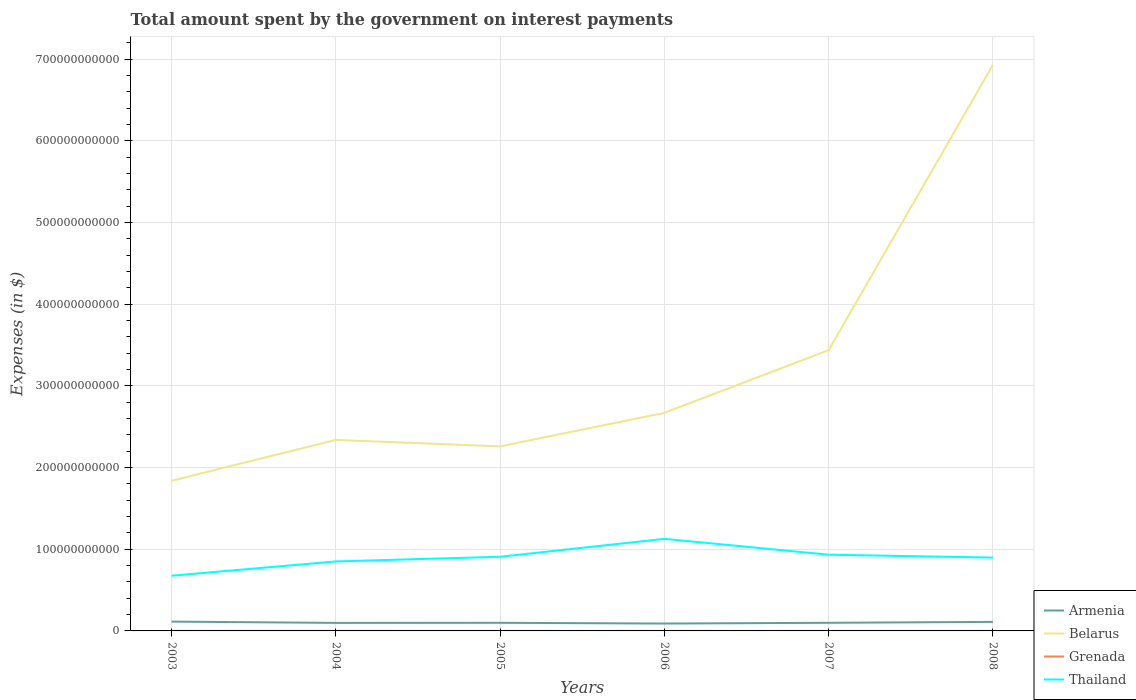How many different coloured lines are there?
Give a very brief answer. 4. Does the line corresponding to Belarus intersect with the line corresponding to Grenada?
Your answer should be very brief. No. Is the number of lines equal to the number of legend labels?
Your answer should be compact. Yes. Across all years, what is the maximum amount spent on interest payments by the government in Thailand?
Keep it short and to the point. 6.76e+1. In which year was the amount spent on interest payments by the government in Grenada maximum?
Ensure brevity in your answer.  2005. What is the total amount spent on interest payments by the government in Belarus in the graph?
Your answer should be very brief. 7.93e+09. What is the difference between the highest and the second highest amount spent on interest payments by the government in Grenada?
Your answer should be very brief. 4.40e+07. What is the difference between the highest and the lowest amount spent on interest payments by the government in Belarus?
Provide a succinct answer. 2. Is the amount spent on interest payments by the government in Thailand strictly greater than the amount spent on interest payments by the government in Grenada over the years?
Offer a very short reply. No. What is the difference between two consecutive major ticks on the Y-axis?
Provide a short and direct response. 1.00e+11. Are the values on the major ticks of Y-axis written in scientific E-notation?
Give a very brief answer. No. What is the title of the graph?
Your answer should be compact. Total amount spent by the government on interest payments. Does "Brunei Darussalam" appear as one of the legend labels in the graph?
Provide a succinct answer. No. What is the label or title of the X-axis?
Keep it short and to the point. Years. What is the label or title of the Y-axis?
Offer a terse response. Expenses (in $). What is the Expenses (in $) in Armenia in 2003?
Offer a terse response. 1.14e+1. What is the Expenses (in $) of Belarus in 2003?
Offer a terse response. 1.84e+11. What is the Expenses (in $) of Grenada in 2003?
Ensure brevity in your answer.  6.31e+07. What is the Expenses (in $) in Thailand in 2003?
Offer a very short reply. 6.76e+1. What is the Expenses (in $) of Armenia in 2004?
Offer a very short reply. 9.83e+09. What is the Expenses (in $) of Belarus in 2004?
Your response must be concise. 2.34e+11. What is the Expenses (in $) in Grenada in 2004?
Keep it short and to the point. 7.18e+07. What is the Expenses (in $) of Thailand in 2004?
Make the answer very short. 8.51e+1. What is the Expenses (in $) in Armenia in 2005?
Your answer should be very brief. 9.93e+09. What is the Expenses (in $) of Belarus in 2005?
Offer a very short reply. 2.26e+11. What is the Expenses (in $) in Grenada in 2005?
Offer a terse response. 2.78e+07. What is the Expenses (in $) of Thailand in 2005?
Your response must be concise. 9.08e+1. What is the Expenses (in $) in Armenia in 2006?
Your response must be concise. 9.02e+09. What is the Expenses (in $) of Belarus in 2006?
Your response must be concise. 2.67e+11. What is the Expenses (in $) of Grenada in 2006?
Your response must be concise. 2.90e+07. What is the Expenses (in $) of Thailand in 2006?
Ensure brevity in your answer.  1.13e+11. What is the Expenses (in $) in Armenia in 2007?
Give a very brief answer. 9.96e+09. What is the Expenses (in $) of Belarus in 2007?
Offer a very short reply. 3.44e+11. What is the Expenses (in $) in Grenada in 2007?
Provide a succinct answer. 3.30e+07. What is the Expenses (in $) of Thailand in 2007?
Provide a succinct answer. 9.33e+1. What is the Expenses (in $) in Armenia in 2008?
Keep it short and to the point. 1.11e+1. What is the Expenses (in $) in Belarus in 2008?
Your response must be concise. 6.93e+11. What is the Expenses (in $) in Grenada in 2008?
Your answer should be compact. 3.49e+07. What is the Expenses (in $) in Thailand in 2008?
Provide a succinct answer. 8.98e+1. Across all years, what is the maximum Expenses (in $) of Armenia?
Your response must be concise. 1.14e+1. Across all years, what is the maximum Expenses (in $) in Belarus?
Ensure brevity in your answer.  6.93e+11. Across all years, what is the maximum Expenses (in $) of Grenada?
Make the answer very short. 7.18e+07. Across all years, what is the maximum Expenses (in $) of Thailand?
Provide a succinct answer. 1.13e+11. Across all years, what is the minimum Expenses (in $) of Armenia?
Make the answer very short. 9.02e+09. Across all years, what is the minimum Expenses (in $) in Belarus?
Your answer should be very brief. 1.84e+11. Across all years, what is the minimum Expenses (in $) of Grenada?
Your answer should be compact. 2.78e+07. Across all years, what is the minimum Expenses (in $) of Thailand?
Give a very brief answer. 6.76e+1. What is the total Expenses (in $) in Armenia in the graph?
Your answer should be very brief. 6.12e+1. What is the total Expenses (in $) of Belarus in the graph?
Give a very brief answer. 1.95e+12. What is the total Expenses (in $) in Grenada in the graph?
Your response must be concise. 2.60e+08. What is the total Expenses (in $) of Thailand in the graph?
Make the answer very short. 5.39e+11. What is the difference between the Expenses (in $) of Armenia in 2003 and that in 2004?
Give a very brief answer. 1.56e+09. What is the difference between the Expenses (in $) in Belarus in 2003 and that in 2004?
Provide a short and direct response. -5.00e+1. What is the difference between the Expenses (in $) of Grenada in 2003 and that in 2004?
Your response must be concise. -8.70e+06. What is the difference between the Expenses (in $) in Thailand in 2003 and that in 2004?
Offer a very short reply. -1.75e+1. What is the difference between the Expenses (in $) of Armenia in 2003 and that in 2005?
Give a very brief answer. 1.46e+09. What is the difference between the Expenses (in $) of Belarus in 2003 and that in 2005?
Provide a short and direct response. -4.20e+1. What is the difference between the Expenses (in $) of Grenada in 2003 and that in 2005?
Keep it short and to the point. 3.53e+07. What is the difference between the Expenses (in $) of Thailand in 2003 and that in 2005?
Give a very brief answer. -2.32e+1. What is the difference between the Expenses (in $) of Armenia in 2003 and that in 2006?
Offer a very short reply. 2.37e+09. What is the difference between the Expenses (in $) of Belarus in 2003 and that in 2006?
Ensure brevity in your answer.  -8.31e+1. What is the difference between the Expenses (in $) of Grenada in 2003 and that in 2006?
Give a very brief answer. 3.41e+07. What is the difference between the Expenses (in $) of Thailand in 2003 and that in 2006?
Ensure brevity in your answer.  -4.52e+1. What is the difference between the Expenses (in $) of Armenia in 2003 and that in 2007?
Provide a succinct answer. 1.44e+09. What is the difference between the Expenses (in $) in Belarus in 2003 and that in 2007?
Offer a very short reply. -1.60e+11. What is the difference between the Expenses (in $) in Grenada in 2003 and that in 2007?
Offer a very short reply. 3.01e+07. What is the difference between the Expenses (in $) of Thailand in 2003 and that in 2007?
Give a very brief answer. -2.57e+1. What is the difference between the Expenses (in $) in Armenia in 2003 and that in 2008?
Ensure brevity in your answer.  3.44e+08. What is the difference between the Expenses (in $) in Belarus in 2003 and that in 2008?
Offer a very short reply. -5.09e+11. What is the difference between the Expenses (in $) of Grenada in 2003 and that in 2008?
Offer a very short reply. 2.82e+07. What is the difference between the Expenses (in $) in Thailand in 2003 and that in 2008?
Give a very brief answer. -2.22e+1. What is the difference between the Expenses (in $) in Armenia in 2004 and that in 2005?
Offer a terse response. -9.82e+07. What is the difference between the Expenses (in $) of Belarus in 2004 and that in 2005?
Your response must be concise. 7.93e+09. What is the difference between the Expenses (in $) in Grenada in 2004 and that in 2005?
Offer a terse response. 4.40e+07. What is the difference between the Expenses (in $) of Thailand in 2004 and that in 2005?
Your answer should be very brief. -5.71e+09. What is the difference between the Expenses (in $) in Armenia in 2004 and that in 2006?
Ensure brevity in your answer.  8.10e+08. What is the difference between the Expenses (in $) of Belarus in 2004 and that in 2006?
Your answer should be very brief. -3.31e+1. What is the difference between the Expenses (in $) in Grenada in 2004 and that in 2006?
Provide a succinct answer. 4.28e+07. What is the difference between the Expenses (in $) of Thailand in 2004 and that in 2006?
Provide a short and direct response. -2.77e+1. What is the difference between the Expenses (in $) of Armenia in 2004 and that in 2007?
Provide a succinct answer. -1.22e+08. What is the difference between the Expenses (in $) in Belarus in 2004 and that in 2007?
Keep it short and to the point. -1.10e+11. What is the difference between the Expenses (in $) in Grenada in 2004 and that in 2007?
Give a very brief answer. 3.88e+07. What is the difference between the Expenses (in $) in Thailand in 2004 and that in 2007?
Provide a succinct answer. -8.24e+09. What is the difference between the Expenses (in $) of Armenia in 2004 and that in 2008?
Ensure brevity in your answer.  -1.22e+09. What is the difference between the Expenses (in $) in Belarus in 2004 and that in 2008?
Your response must be concise. -4.59e+11. What is the difference between the Expenses (in $) of Grenada in 2004 and that in 2008?
Offer a terse response. 3.69e+07. What is the difference between the Expenses (in $) of Thailand in 2004 and that in 2008?
Provide a short and direct response. -4.69e+09. What is the difference between the Expenses (in $) in Armenia in 2005 and that in 2006?
Keep it short and to the point. 9.09e+08. What is the difference between the Expenses (in $) in Belarus in 2005 and that in 2006?
Offer a very short reply. -4.11e+1. What is the difference between the Expenses (in $) of Grenada in 2005 and that in 2006?
Keep it short and to the point. -1.20e+06. What is the difference between the Expenses (in $) in Thailand in 2005 and that in 2006?
Your answer should be very brief. -2.19e+1. What is the difference between the Expenses (in $) of Armenia in 2005 and that in 2007?
Ensure brevity in your answer.  -2.36e+07. What is the difference between the Expenses (in $) in Belarus in 2005 and that in 2007?
Give a very brief answer. -1.18e+11. What is the difference between the Expenses (in $) in Grenada in 2005 and that in 2007?
Provide a succinct answer. -5.20e+06. What is the difference between the Expenses (in $) of Thailand in 2005 and that in 2007?
Ensure brevity in your answer.  -2.53e+09. What is the difference between the Expenses (in $) of Armenia in 2005 and that in 2008?
Offer a very short reply. -1.12e+09. What is the difference between the Expenses (in $) in Belarus in 2005 and that in 2008?
Provide a succinct answer. -4.67e+11. What is the difference between the Expenses (in $) in Grenada in 2005 and that in 2008?
Offer a very short reply. -7.10e+06. What is the difference between the Expenses (in $) in Thailand in 2005 and that in 2008?
Provide a succinct answer. 1.02e+09. What is the difference between the Expenses (in $) in Armenia in 2006 and that in 2007?
Ensure brevity in your answer.  -9.32e+08. What is the difference between the Expenses (in $) of Belarus in 2006 and that in 2007?
Keep it short and to the point. -7.68e+1. What is the difference between the Expenses (in $) in Thailand in 2006 and that in 2007?
Your answer should be compact. 1.94e+1. What is the difference between the Expenses (in $) of Armenia in 2006 and that in 2008?
Your answer should be compact. -2.03e+09. What is the difference between the Expenses (in $) in Belarus in 2006 and that in 2008?
Provide a succinct answer. -4.26e+11. What is the difference between the Expenses (in $) in Grenada in 2006 and that in 2008?
Give a very brief answer. -5.90e+06. What is the difference between the Expenses (in $) in Thailand in 2006 and that in 2008?
Make the answer very short. 2.30e+1. What is the difference between the Expenses (in $) of Armenia in 2007 and that in 2008?
Offer a terse response. -1.10e+09. What is the difference between the Expenses (in $) of Belarus in 2007 and that in 2008?
Offer a very short reply. -3.49e+11. What is the difference between the Expenses (in $) in Grenada in 2007 and that in 2008?
Your answer should be compact. -1.90e+06. What is the difference between the Expenses (in $) of Thailand in 2007 and that in 2008?
Your response must be concise. 3.55e+09. What is the difference between the Expenses (in $) of Armenia in 2003 and the Expenses (in $) of Belarus in 2004?
Ensure brevity in your answer.  -2.23e+11. What is the difference between the Expenses (in $) of Armenia in 2003 and the Expenses (in $) of Grenada in 2004?
Offer a terse response. 1.13e+1. What is the difference between the Expenses (in $) of Armenia in 2003 and the Expenses (in $) of Thailand in 2004?
Keep it short and to the point. -7.37e+1. What is the difference between the Expenses (in $) of Belarus in 2003 and the Expenses (in $) of Grenada in 2004?
Provide a short and direct response. 1.84e+11. What is the difference between the Expenses (in $) in Belarus in 2003 and the Expenses (in $) in Thailand in 2004?
Make the answer very short. 9.88e+1. What is the difference between the Expenses (in $) of Grenada in 2003 and the Expenses (in $) of Thailand in 2004?
Offer a very short reply. -8.50e+1. What is the difference between the Expenses (in $) in Armenia in 2003 and the Expenses (in $) in Belarus in 2005?
Your answer should be very brief. -2.15e+11. What is the difference between the Expenses (in $) in Armenia in 2003 and the Expenses (in $) in Grenada in 2005?
Offer a very short reply. 1.14e+1. What is the difference between the Expenses (in $) in Armenia in 2003 and the Expenses (in $) in Thailand in 2005?
Your answer should be very brief. -7.94e+1. What is the difference between the Expenses (in $) in Belarus in 2003 and the Expenses (in $) in Grenada in 2005?
Make the answer very short. 1.84e+11. What is the difference between the Expenses (in $) of Belarus in 2003 and the Expenses (in $) of Thailand in 2005?
Your answer should be compact. 9.31e+1. What is the difference between the Expenses (in $) of Grenada in 2003 and the Expenses (in $) of Thailand in 2005?
Offer a very short reply. -9.08e+1. What is the difference between the Expenses (in $) in Armenia in 2003 and the Expenses (in $) in Belarus in 2006?
Provide a succinct answer. -2.56e+11. What is the difference between the Expenses (in $) of Armenia in 2003 and the Expenses (in $) of Grenada in 2006?
Keep it short and to the point. 1.14e+1. What is the difference between the Expenses (in $) in Armenia in 2003 and the Expenses (in $) in Thailand in 2006?
Provide a short and direct response. -1.01e+11. What is the difference between the Expenses (in $) of Belarus in 2003 and the Expenses (in $) of Grenada in 2006?
Your answer should be compact. 1.84e+11. What is the difference between the Expenses (in $) in Belarus in 2003 and the Expenses (in $) in Thailand in 2006?
Keep it short and to the point. 7.12e+1. What is the difference between the Expenses (in $) in Grenada in 2003 and the Expenses (in $) in Thailand in 2006?
Your answer should be very brief. -1.13e+11. What is the difference between the Expenses (in $) of Armenia in 2003 and the Expenses (in $) of Belarus in 2007?
Provide a short and direct response. -3.32e+11. What is the difference between the Expenses (in $) of Armenia in 2003 and the Expenses (in $) of Grenada in 2007?
Your response must be concise. 1.14e+1. What is the difference between the Expenses (in $) of Armenia in 2003 and the Expenses (in $) of Thailand in 2007?
Your answer should be very brief. -8.19e+1. What is the difference between the Expenses (in $) in Belarus in 2003 and the Expenses (in $) in Grenada in 2007?
Provide a short and direct response. 1.84e+11. What is the difference between the Expenses (in $) of Belarus in 2003 and the Expenses (in $) of Thailand in 2007?
Offer a very short reply. 9.06e+1. What is the difference between the Expenses (in $) in Grenada in 2003 and the Expenses (in $) in Thailand in 2007?
Your response must be concise. -9.33e+1. What is the difference between the Expenses (in $) of Armenia in 2003 and the Expenses (in $) of Belarus in 2008?
Make the answer very short. -6.82e+11. What is the difference between the Expenses (in $) of Armenia in 2003 and the Expenses (in $) of Grenada in 2008?
Offer a very short reply. 1.14e+1. What is the difference between the Expenses (in $) in Armenia in 2003 and the Expenses (in $) in Thailand in 2008?
Keep it short and to the point. -7.84e+1. What is the difference between the Expenses (in $) of Belarus in 2003 and the Expenses (in $) of Grenada in 2008?
Provide a succinct answer. 1.84e+11. What is the difference between the Expenses (in $) of Belarus in 2003 and the Expenses (in $) of Thailand in 2008?
Your answer should be compact. 9.42e+1. What is the difference between the Expenses (in $) of Grenada in 2003 and the Expenses (in $) of Thailand in 2008?
Your answer should be compact. -8.97e+1. What is the difference between the Expenses (in $) of Armenia in 2004 and the Expenses (in $) of Belarus in 2005?
Offer a very short reply. -2.16e+11. What is the difference between the Expenses (in $) in Armenia in 2004 and the Expenses (in $) in Grenada in 2005?
Keep it short and to the point. 9.81e+09. What is the difference between the Expenses (in $) of Armenia in 2004 and the Expenses (in $) of Thailand in 2005?
Provide a short and direct response. -8.10e+1. What is the difference between the Expenses (in $) of Belarus in 2004 and the Expenses (in $) of Grenada in 2005?
Offer a terse response. 2.34e+11. What is the difference between the Expenses (in $) in Belarus in 2004 and the Expenses (in $) in Thailand in 2005?
Offer a very short reply. 1.43e+11. What is the difference between the Expenses (in $) in Grenada in 2004 and the Expenses (in $) in Thailand in 2005?
Offer a terse response. -9.07e+1. What is the difference between the Expenses (in $) of Armenia in 2004 and the Expenses (in $) of Belarus in 2006?
Ensure brevity in your answer.  -2.57e+11. What is the difference between the Expenses (in $) in Armenia in 2004 and the Expenses (in $) in Grenada in 2006?
Provide a short and direct response. 9.81e+09. What is the difference between the Expenses (in $) of Armenia in 2004 and the Expenses (in $) of Thailand in 2006?
Give a very brief answer. -1.03e+11. What is the difference between the Expenses (in $) of Belarus in 2004 and the Expenses (in $) of Grenada in 2006?
Offer a terse response. 2.34e+11. What is the difference between the Expenses (in $) of Belarus in 2004 and the Expenses (in $) of Thailand in 2006?
Your response must be concise. 1.21e+11. What is the difference between the Expenses (in $) in Grenada in 2004 and the Expenses (in $) in Thailand in 2006?
Keep it short and to the point. -1.13e+11. What is the difference between the Expenses (in $) in Armenia in 2004 and the Expenses (in $) in Belarus in 2007?
Your answer should be very brief. -3.34e+11. What is the difference between the Expenses (in $) of Armenia in 2004 and the Expenses (in $) of Grenada in 2007?
Make the answer very short. 9.80e+09. What is the difference between the Expenses (in $) in Armenia in 2004 and the Expenses (in $) in Thailand in 2007?
Your response must be concise. -8.35e+1. What is the difference between the Expenses (in $) of Belarus in 2004 and the Expenses (in $) of Grenada in 2007?
Your answer should be compact. 2.34e+11. What is the difference between the Expenses (in $) in Belarus in 2004 and the Expenses (in $) in Thailand in 2007?
Provide a short and direct response. 1.41e+11. What is the difference between the Expenses (in $) of Grenada in 2004 and the Expenses (in $) of Thailand in 2007?
Ensure brevity in your answer.  -9.33e+1. What is the difference between the Expenses (in $) of Armenia in 2004 and the Expenses (in $) of Belarus in 2008?
Keep it short and to the point. -6.83e+11. What is the difference between the Expenses (in $) of Armenia in 2004 and the Expenses (in $) of Grenada in 2008?
Offer a very short reply. 9.80e+09. What is the difference between the Expenses (in $) of Armenia in 2004 and the Expenses (in $) of Thailand in 2008?
Offer a very short reply. -8.00e+1. What is the difference between the Expenses (in $) of Belarus in 2004 and the Expenses (in $) of Grenada in 2008?
Provide a short and direct response. 2.34e+11. What is the difference between the Expenses (in $) in Belarus in 2004 and the Expenses (in $) in Thailand in 2008?
Ensure brevity in your answer.  1.44e+11. What is the difference between the Expenses (in $) in Grenada in 2004 and the Expenses (in $) in Thailand in 2008?
Your answer should be very brief. -8.97e+1. What is the difference between the Expenses (in $) of Armenia in 2005 and the Expenses (in $) of Belarus in 2006?
Provide a short and direct response. -2.57e+11. What is the difference between the Expenses (in $) in Armenia in 2005 and the Expenses (in $) in Grenada in 2006?
Your answer should be very brief. 9.90e+09. What is the difference between the Expenses (in $) of Armenia in 2005 and the Expenses (in $) of Thailand in 2006?
Make the answer very short. -1.03e+11. What is the difference between the Expenses (in $) of Belarus in 2005 and the Expenses (in $) of Grenada in 2006?
Offer a very short reply. 2.26e+11. What is the difference between the Expenses (in $) in Belarus in 2005 and the Expenses (in $) in Thailand in 2006?
Ensure brevity in your answer.  1.13e+11. What is the difference between the Expenses (in $) of Grenada in 2005 and the Expenses (in $) of Thailand in 2006?
Your answer should be very brief. -1.13e+11. What is the difference between the Expenses (in $) in Armenia in 2005 and the Expenses (in $) in Belarus in 2007?
Ensure brevity in your answer.  -3.34e+11. What is the difference between the Expenses (in $) in Armenia in 2005 and the Expenses (in $) in Grenada in 2007?
Ensure brevity in your answer.  9.90e+09. What is the difference between the Expenses (in $) in Armenia in 2005 and the Expenses (in $) in Thailand in 2007?
Give a very brief answer. -8.34e+1. What is the difference between the Expenses (in $) in Belarus in 2005 and the Expenses (in $) in Grenada in 2007?
Offer a very short reply. 2.26e+11. What is the difference between the Expenses (in $) in Belarus in 2005 and the Expenses (in $) in Thailand in 2007?
Make the answer very short. 1.33e+11. What is the difference between the Expenses (in $) of Grenada in 2005 and the Expenses (in $) of Thailand in 2007?
Your response must be concise. -9.33e+1. What is the difference between the Expenses (in $) of Armenia in 2005 and the Expenses (in $) of Belarus in 2008?
Make the answer very short. -6.83e+11. What is the difference between the Expenses (in $) in Armenia in 2005 and the Expenses (in $) in Grenada in 2008?
Offer a terse response. 9.90e+09. What is the difference between the Expenses (in $) of Armenia in 2005 and the Expenses (in $) of Thailand in 2008?
Offer a very short reply. -7.99e+1. What is the difference between the Expenses (in $) of Belarus in 2005 and the Expenses (in $) of Grenada in 2008?
Keep it short and to the point. 2.26e+11. What is the difference between the Expenses (in $) in Belarus in 2005 and the Expenses (in $) in Thailand in 2008?
Provide a succinct answer. 1.36e+11. What is the difference between the Expenses (in $) in Grenada in 2005 and the Expenses (in $) in Thailand in 2008?
Ensure brevity in your answer.  -8.98e+1. What is the difference between the Expenses (in $) in Armenia in 2006 and the Expenses (in $) in Belarus in 2007?
Offer a very short reply. -3.35e+11. What is the difference between the Expenses (in $) of Armenia in 2006 and the Expenses (in $) of Grenada in 2007?
Keep it short and to the point. 8.99e+09. What is the difference between the Expenses (in $) of Armenia in 2006 and the Expenses (in $) of Thailand in 2007?
Offer a terse response. -8.43e+1. What is the difference between the Expenses (in $) in Belarus in 2006 and the Expenses (in $) in Grenada in 2007?
Your response must be concise. 2.67e+11. What is the difference between the Expenses (in $) in Belarus in 2006 and the Expenses (in $) in Thailand in 2007?
Provide a succinct answer. 1.74e+11. What is the difference between the Expenses (in $) of Grenada in 2006 and the Expenses (in $) of Thailand in 2007?
Make the answer very short. -9.33e+1. What is the difference between the Expenses (in $) of Armenia in 2006 and the Expenses (in $) of Belarus in 2008?
Offer a terse response. -6.84e+11. What is the difference between the Expenses (in $) in Armenia in 2006 and the Expenses (in $) in Grenada in 2008?
Your answer should be compact. 8.99e+09. What is the difference between the Expenses (in $) in Armenia in 2006 and the Expenses (in $) in Thailand in 2008?
Provide a short and direct response. -8.08e+1. What is the difference between the Expenses (in $) of Belarus in 2006 and the Expenses (in $) of Grenada in 2008?
Your answer should be very brief. 2.67e+11. What is the difference between the Expenses (in $) of Belarus in 2006 and the Expenses (in $) of Thailand in 2008?
Keep it short and to the point. 1.77e+11. What is the difference between the Expenses (in $) of Grenada in 2006 and the Expenses (in $) of Thailand in 2008?
Your answer should be very brief. -8.98e+1. What is the difference between the Expenses (in $) in Armenia in 2007 and the Expenses (in $) in Belarus in 2008?
Keep it short and to the point. -6.83e+11. What is the difference between the Expenses (in $) of Armenia in 2007 and the Expenses (in $) of Grenada in 2008?
Your response must be concise. 9.92e+09. What is the difference between the Expenses (in $) of Armenia in 2007 and the Expenses (in $) of Thailand in 2008?
Your answer should be compact. -7.98e+1. What is the difference between the Expenses (in $) of Belarus in 2007 and the Expenses (in $) of Grenada in 2008?
Your answer should be compact. 3.44e+11. What is the difference between the Expenses (in $) of Belarus in 2007 and the Expenses (in $) of Thailand in 2008?
Give a very brief answer. 2.54e+11. What is the difference between the Expenses (in $) in Grenada in 2007 and the Expenses (in $) in Thailand in 2008?
Provide a succinct answer. -8.98e+1. What is the average Expenses (in $) of Armenia per year?
Make the answer very short. 1.02e+1. What is the average Expenses (in $) of Belarus per year?
Offer a terse response. 3.25e+11. What is the average Expenses (in $) in Grenada per year?
Your response must be concise. 4.33e+07. What is the average Expenses (in $) of Thailand per year?
Keep it short and to the point. 8.99e+1. In the year 2003, what is the difference between the Expenses (in $) of Armenia and Expenses (in $) of Belarus?
Your response must be concise. -1.73e+11. In the year 2003, what is the difference between the Expenses (in $) in Armenia and Expenses (in $) in Grenada?
Provide a succinct answer. 1.13e+1. In the year 2003, what is the difference between the Expenses (in $) of Armenia and Expenses (in $) of Thailand?
Your answer should be very brief. -5.62e+1. In the year 2003, what is the difference between the Expenses (in $) of Belarus and Expenses (in $) of Grenada?
Offer a very short reply. 1.84e+11. In the year 2003, what is the difference between the Expenses (in $) in Belarus and Expenses (in $) in Thailand?
Your answer should be very brief. 1.16e+11. In the year 2003, what is the difference between the Expenses (in $) in Grenada and Expenses (in $) in Thailand?
Ensure brevity in your answer.  -6.75e+1. In the year 2004, what is the difference between the Expenses (in $) in Armenia and Expenses (in $) in Belarus?
Your answer should be very brief. -2.24e+11. In the year 2004, what is the difference between the Expenses (in $) in Armenia and Expenses (in $) in Grenada?
Keep it short and to the point. 9.76e+09. In the year 2004, what is the difference between the Expenses (in $) of Armenia and Expenses (in $) of Thailand?
Keep it short and to the point. -7.53e+1. In the year 2004, what is the difference between the Expenses (in $) in Belarus and Expenses (in $) in Grenada?
Give a very brief answer. 2.34e+11. In the year 2004, what is the difference between the Expenses (in $) in Belarus and Expenses (in $) in Thailand?
Provide a short and direct response. 1.49e+11. In the year 2004, what is the difference between the Expenses (in $) in Grenada and Expenses (in $) in Thailand?
Offer a terse response. -8.50e+1. In the year 2005, what is the difference between the Expenses (in $) of Armenia and Expenses (in $) of Belarus?
Offer a very short reply. -2.16e+11. In the year 2005, what is the difference between the Expenses (in $) in Armenia and Expenses (in $) in Grenada?
Make the answer very short. 9.91e+09. In the year 2005, what is the difference between the Expenses (in $) of Armenia and Expenses (in $) of Thailand?
Offer a very short reply. -8.09e+1. In the year 2005, what is the difference between the Expenses (in $) of Belarus and Expenses (in $) of Grenada?
Offer a terse response. 2.26e+11. In the year 2005, what is the difference between the Expenses (in $) of Belarus and Expenses (in $) of Thailand?
Provide a short and direct response. 1.35e+11. In the year 2005, what is the difference between the Expenses (in $) of Grenada and Expenses (in $) of Thailand?
Your response must be concise. -9.08e+1. In the year 2006, what is the difference between the Expenses (in $) in Armenia and Expenses (in $) in Belarus?
Your answer should be compact. -2.58e+11. In the year 2006, what is the difference between the Expenses (in $) of Armenia and Expenses (in $) of Grenada?
Offer a very short reply. 9.00e+09. In the year 2006, what is the difference between the Expenses (in $) in Armenia and Expenses (in $) in Thailand?
Your answer should be compact. -1.04e+11. In the year 2006, what is the difference between the Expenses (in $) of Belarus and Expenses (in $) of Grenada?
Your response must be concise. 2.67e+11. In the year 2006, what is the difference between the Expenses (in $) in Belarus and Expenses (in $) in Thailand?
Your response must be concise. 1.54e+11. In the year 2006, what is the difference between the Expenses (in $) in Grenada and Expenses (in $) in Thailand?
Your response must be concise. -1.13e+11. In the year 2007, what is the difference between the Expenses (in $) of Armenia and Expenses (in $) of Belarus?
Ensure brevity in your answer.  -3.34e+11. In the year 2007, what is the difference between the Expenses (in $) of Armenia and Expenses (in $) of Grenada?
Your response must be concise. 9.92e+09. In the year 2007, what is the difference between the Expenses (in $) of Armenia and Expenses (in $) of Thailand?
Offer a very short reply. -8.34e+1. In the year 2007, what is the difference between the Expenses (in $) in Belarus and Expenses (in $) in Grenada?
Keep it short and to the point. 3.44e+11. In the year 2007, what is the difference between the Expenses (in $) in Belarus and Expenses (in $) in Thailand?
Ensure brevity in your answer.  2.51e+11. In the year 2007, what is the difference between the Expenses (in $) of Grenada and Expenses (in $) of Thailand?
Keep it short and to the point. -9.33e+1. In the year 2008, what is the difference between the Expenses (in $) of Armenia and Expenses (in $) of Belarus?
Keep it short and to the point. -6.82e+11. In the year 2008, what is the difference between the Expenses (in $) in Armenia and Expenses (in $) in Grenada?
Your answer should be very brief. 1.10e+1. In the year 2008, what is the difference between the Expenses (in $) of Armenia and Expenses (in $) of Thailand?
Your response must be concise. -7.87e+1. In the year 2008, what is the difference between the Expenses (in $) in Belarus and Expenses (in $) in Grenada?
Your answer should be very brief. 6.93e+11. In the year 2008, what is the difference between the Expenses (in $) in Belarus and Expenses (in $) in Thailand?
Offer a very short reply. 6.03e+11. In the year 2008, what is the difference between the Expenses (in $) in Grenada and Expenses (in $) in Thailand?
Ensure brevity in your answer.  -8.98e+1. What is the ratio of the Expenses (in $) in Armenia in 2003 to that in 2004?
Provide a succinct answer. 1.16. What is the ratio of the Expenses (in $) in Belarus in 2003 to that in 2004?
Ensure brevity in your answer.  0.79. What is the ratio of the Expenses (in $) in Grenada in 2003 to that in 2004?
Make the answer very short. 0.88. What is the ratio of the Expenses (in $) in Thailand in 2003 to that in 2004?
Offer a terse response. 0.79. What is the ratio of the Expenses (in $) of Armenia in 2003 to that in 2005?
Keep it short and to the point. 1.15. What is the ratio of the Expenses (in $) of Belarus in 2003 to that in 2005?
Your answer should be compact. 0.81. What is the ratio of the Expenses (in $) of Grenada in 2003 to that in 2005?
Provide a succinct answer. 2.27. What is the ratio of the Expenses (in $) in Thailand in 2003 to that in 2005?
Ensure brevity in your answer.  0.74. What is the ratio of the Expenses (in $) in Armenia in 2003 to that in 2006?
Your answer should be very brief. 1.26. What is the ratio of the Expenses (in $) of Belarus in 2003 to that in 2006?
Keep it short and to the point. 0.69. What is the ratio of the Expenses (in $) of Grenada in 2003 to that in 2006?
Provide a short and direct response. 2.18. What is the ratio of the Expenses (in $) in Thailand in 2003 to that in 2006?
Provide a short and direct response. 0.6. What is the ratio of the Expenses (in $) in Armenia in 2003 to that in 2007?
Your answer should be very brief. 1.14. What is the ratio of the Expenses (in $) in Belarus in 2003 to that in 2007?
Your answer should be very brief. 0.53. What is the ratio of the Expenses (in $) of Grenada in 2003 to that in 2007?
Provide a short and direct response. 1.91. What is the ratio of the Expenses (in $) in Thailand in 2003 to that in 2007?
Make the answer very short. 0.72. What is the ratio of the Expenses (in $) of Armenia in 2003 to that in 2008?
Your answer should be very brief. 1.03. What is the ratio of the Expenses (in $) in Belarus in 2003 to that in 2008?
Your response must be concise. 0.27. What is the ratio of the Expenses (in $) of Grenada in 2003 to that in 2008?
Make the answer very short. 1.81. What is the ratio of the Expenses (in $) of Thailand in 2003 to that in 2008?
Provide a short and direct response. 0.75. What is the ratio of the Expenses (in $) of Armenia in 2004 to that in 2005?
Provide a short and direct response. 0.99. What is the ratio of the Expenses (in $) in Belarus in 2004 to that in 2005?
Your answer should be compact. 1.04. What is the ratio of the Expenses (in $) in Grenada in 2004 to that in 2005?
Provide a succinct answer. 2.58. What is the ratio of the Expenses (in $) of Thailand in 2004 to that in 2005?
Ensure brevity in your answer.  0.94. What is the ratio of the Expenses (in $) in Armenia in 2004 to that in 2006?
Provide a short and direct response. 1.09. What is the ratio of the Expenses (in $) of Belarus in 2004 to that in 2006?
Provide a short and direct response. 0.88. What is the ratio of the Expenses (in $) of Grenada in 2004 to that in 2006?
Offer a terse response. 2.48. What is the ratio of the Expenses (in $) in Thailand in 2004 to that in 2006?
Offer a very short reply. 0.75. What is the ratio of the Expenses (in $) of Armenia in 2004 to that in 2007?
Offer a very short reply. 0.99. What is the ratio of the Expenses (in $) of Belarus in 2004 to that in 2007?
Keep it short and to the point. 0.68. What is the ratio of the Expenses (in $) of Grenada in 2004 to that in 2007?
Provide a succinct answer. 2.18. What is the ratio of the Expenses (in $) of Thailand in 2004 to that in 2007?
Make the answer very short. 0.91. What is the ratio of the Expenses (in $) in Armenia in 2004 to that in 2008?
Ensure brevity in your answer.  0.89. What is the ratio of the Expenses (in $) in Belarus in 2004 to that in 2008?
Your answer should be very brief. 0.34. What is the ratio of the Expenses (in $) in Grenada in 2004 to that in 2008?
Ensure brevity in your answer.  2.06. What is the ratio of the Expenses (in $) in Thailand in 2004 to that in 2008?
Provide a succinct answer. 0.95. What is the ratio of the Expenses (in $) of Armenia in 2005 to that in 2006?
Give a very brief answer. 1.1. What is the ratio of the Expenses (in $) of Belarus in 2005 to that in 2006?
Your answer should be very brief. 0.85. What is the ratio of the Expenses (in $) of Grenada in 2005 to that in 2006?
Keep it short and to the point. 0.96. What is the ratio of the Expenses (in $) in Thailand in 2005 to that in 2006?
Your response must be concise. 0.81. What is the ratio of the Expenses (in $) of Armenia in 2005 to that in 2007?
Your answer should be very brief. 1. What is the ratio of the Expenses (in $) of Belarus in 2005 to that in 2007?
Keep it short and to the point. 0.66. What is the ratio of the Expenses (in $) in Grenada in 2005 to that in 2007?
Provide a short and direct response. 0.84. What is the ratio of the Expenses (in $) of Thailand in 2005 to that in 2007?
Give a very brief answer. 0.97. What is the ratio of the Expenses (in $) in Armenia in 2005 to that in 2008?
Ensure brevity in your answer.  0.9. What is the ratio of the Expenses (in $) in Belarus in 2005 to that in 2008?
Keep it short and to the point. 0.33. What is the ratio of the Expenses (in $) of Grenada in 2005 to that in 2008?
Keep it short and to the point. 0.8. What is the ratio of the Expenses (in $) of Thailand in 2005 to that in 2008?
Your response must be concise. 1.01. What is the ratio of the Expenses (in $) of Armenia in 2006 to that in 2007?
Ensure brevity in your answer.  0.91. What is the ratio of the Expenses (in $) in Belarus in 2006 to that in 2007?
Ensure brevity in your answer.  0.78. What is the ratio of the Expenses (in $) in Grenada in 2006 to that in 2007?
Offer a very short reply. 0.88. What is the ratio of the Expenses (in $) of Thailand in 2006 to that in 2007?
Provide a succinct answer. 1.21. What is the ratio of the Expenses (in $) of Armenia in 2006 to that in 2008?
Offer a terse response. 0.82. What is the ratio of the Expenses (in $) of Belarus in 2006 to that in 2008?
Give a very brief answer. 0.39. What is the ratio of the Expenses (in $) of Grenada in 2006 to that in 2008?
Make the answer very short. 0.83. What is the ratio of the Expenses (in $) in Thailand in 2006 to that in 2008?
Make the answer very short. 1.26. What is the ratio of the Expenses (in $) of Armenia in 2007 to that in 2008?
Provide a succinct answer. 0.9. What is the ratio of the Expenses (in $) in Belarus in 2007 to that in 2008?
Provide a short and direct response. 0.5. What is the ratio of the Expenses (in $) of Grenada in 2007 to that in 2008?
Ensure brevity in your answer.  0.95. What is the ratio of the Expenses (in $) of Thailand in 2007 to that in 2008?
Make the answer very short. 1.04. What is the difference between the highest and the second highest Expenses (in $) of Armenia?
Provide a short and direct response. 3.44e+08. What is the difference between the highest and the second highest Expenses (in $) in Belarus?
Make the answer very short. 3.49e+11. What is the difference between the highest and the second highest Expenses (in $) of Grenada?
Your response must be concise. 8.70e+06. What is the difference between the highest and the second highest Expenses (in $) of Thailand?
Make the answer very short. 1.94e+1. What is the difference between the highest and the lowest Expenses (in $) in Armenia?
Your answer should be very brief. 2.37e+09. What is the difference between the highest and the lowest Expenses (in $) of Belarus?
Make the answer very short. 5.09e+11. What is the difference between the highest and the lowest Expenses (in $) of Grenada?
Offer a very short reply. 4.40e+07. What is the difference between the highest and the lowest Expenses (in $) of Thailand?
Give a very brief answer. 4.52e+1. 